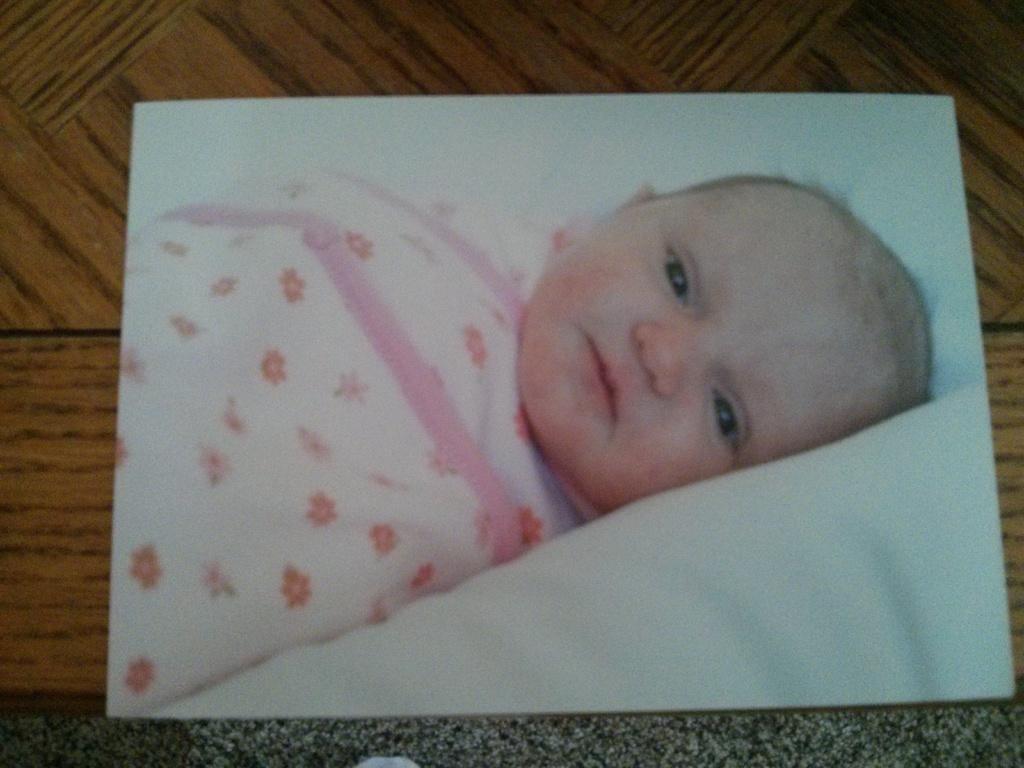Describe this image in one or two sentences. In this image, this looks like a frame. I can see the picture of a baby lying on the bed. I think this frame is placed on the wooden board. 